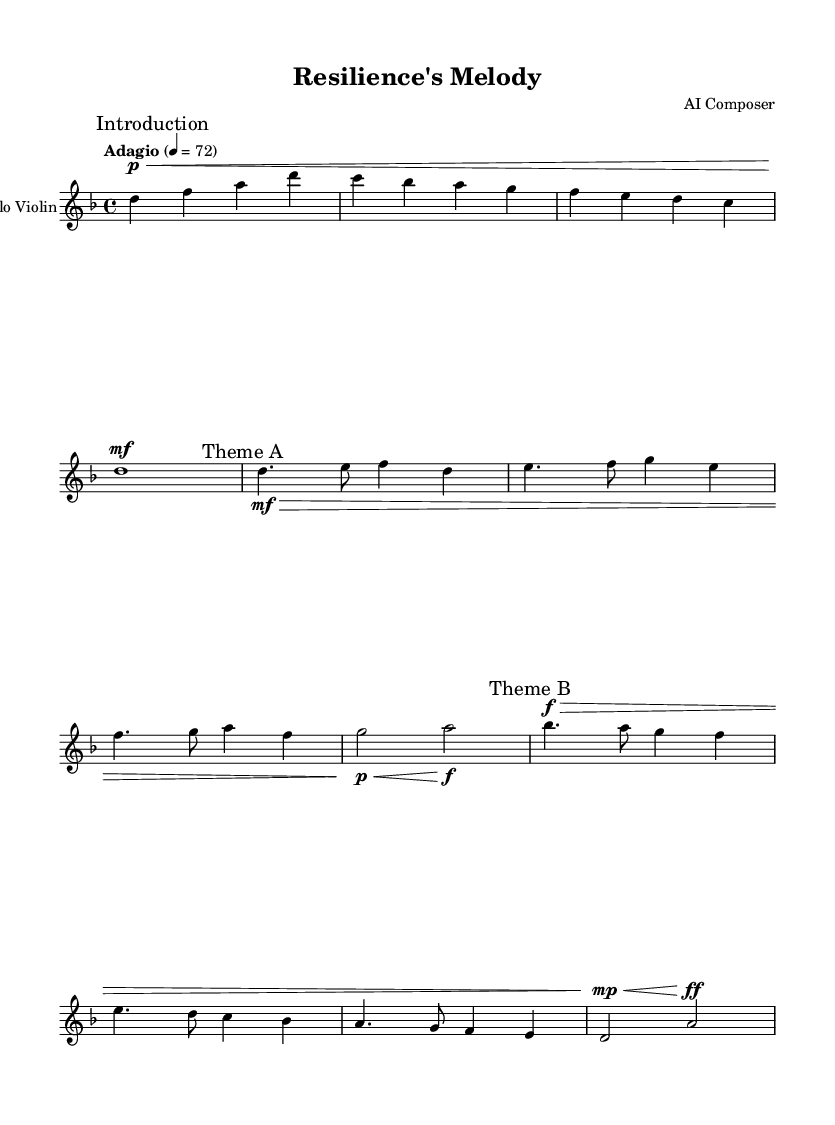What is the key signature of this music? The key signature is two flats, indicated by the presence of B flat and E flat, which are notated in the key signature area of the staff.
Answer: D minor What is the time signature of this piece? The time signature is 4/4, as shown at the beginning of the sheet music next to the key signature. This indicates four beats per measure, with a quarter note getting one beat.
Answer: 4/4 What is the tempo marking for this piece? The tempo marking "Adagio" indicates a slow pace, typically around 66 to 76 beats per minute, which is explicitly stated at the start of the score.
Answer: Adagio How many measures are there in the score? The score has six measures, which can be counted by identifying each group of notes separated by vertical lines indicating the end of a measure.
Answer: 6 What dynamic marking is used at the introduction? The dynamic marking is "p" (piano), indicating soft play, and it is placed right at the start of the introduction.
Answer: piano Which theme appears first in the music? Theme A appears first, as indicated by the label "Theme A" in the music and is characterized by specific melodic content unique to this section.
Answer: Theme A What type of music genre is reflected in this sheet music? The sheet music reflects the Romantic genre, which is noted for its emotional expressiveness and complexity, as exemplified by the use of dynamics and thematic development.
Answer: Romantic 